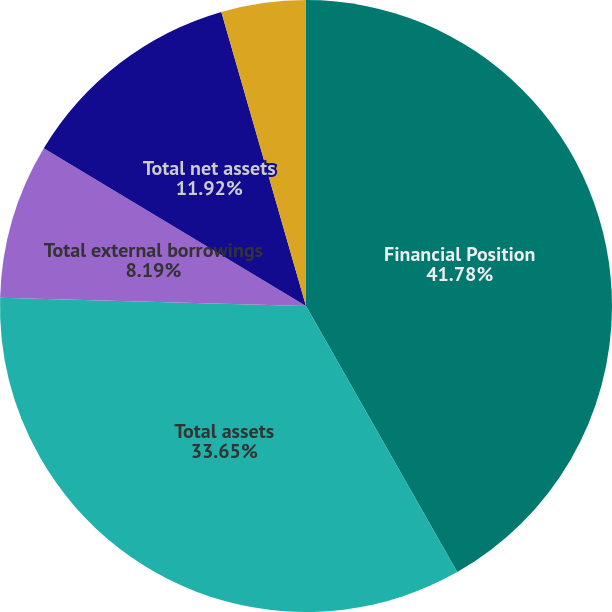<chart> <loc_0><loc_0><loc_500><loc_500><pie_chart><fcel>Financial Position<fcel>Total assets<fcel>Total external borrowings<fcel>Total net assets<fcel>Deere & Company's share of the<nl><fcel>41.77%<fcel>33.65%<fcel>8.19%<fcel>11.92%<fcel>4.46%<nl></chart> 